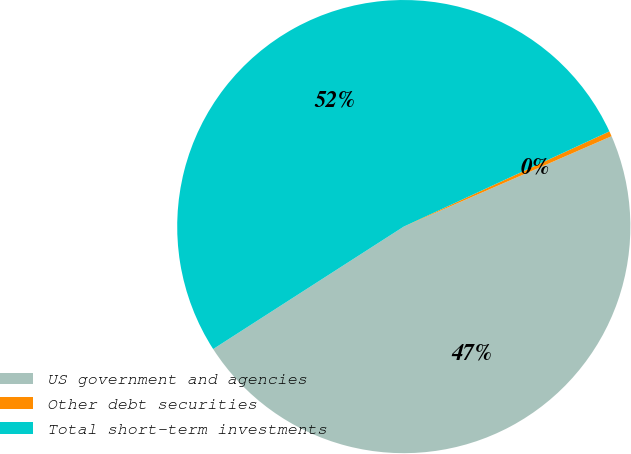Convert chart. <chart><loc_0><loc_0><loc_500><loc_500><pie_chart><fcel>US government and agencies<fcel>Other debt securities<fcel>Total short-term investments<nl><fcel>47.44%<fcel>0.37%<fcel>52.19%<nl></chart> 